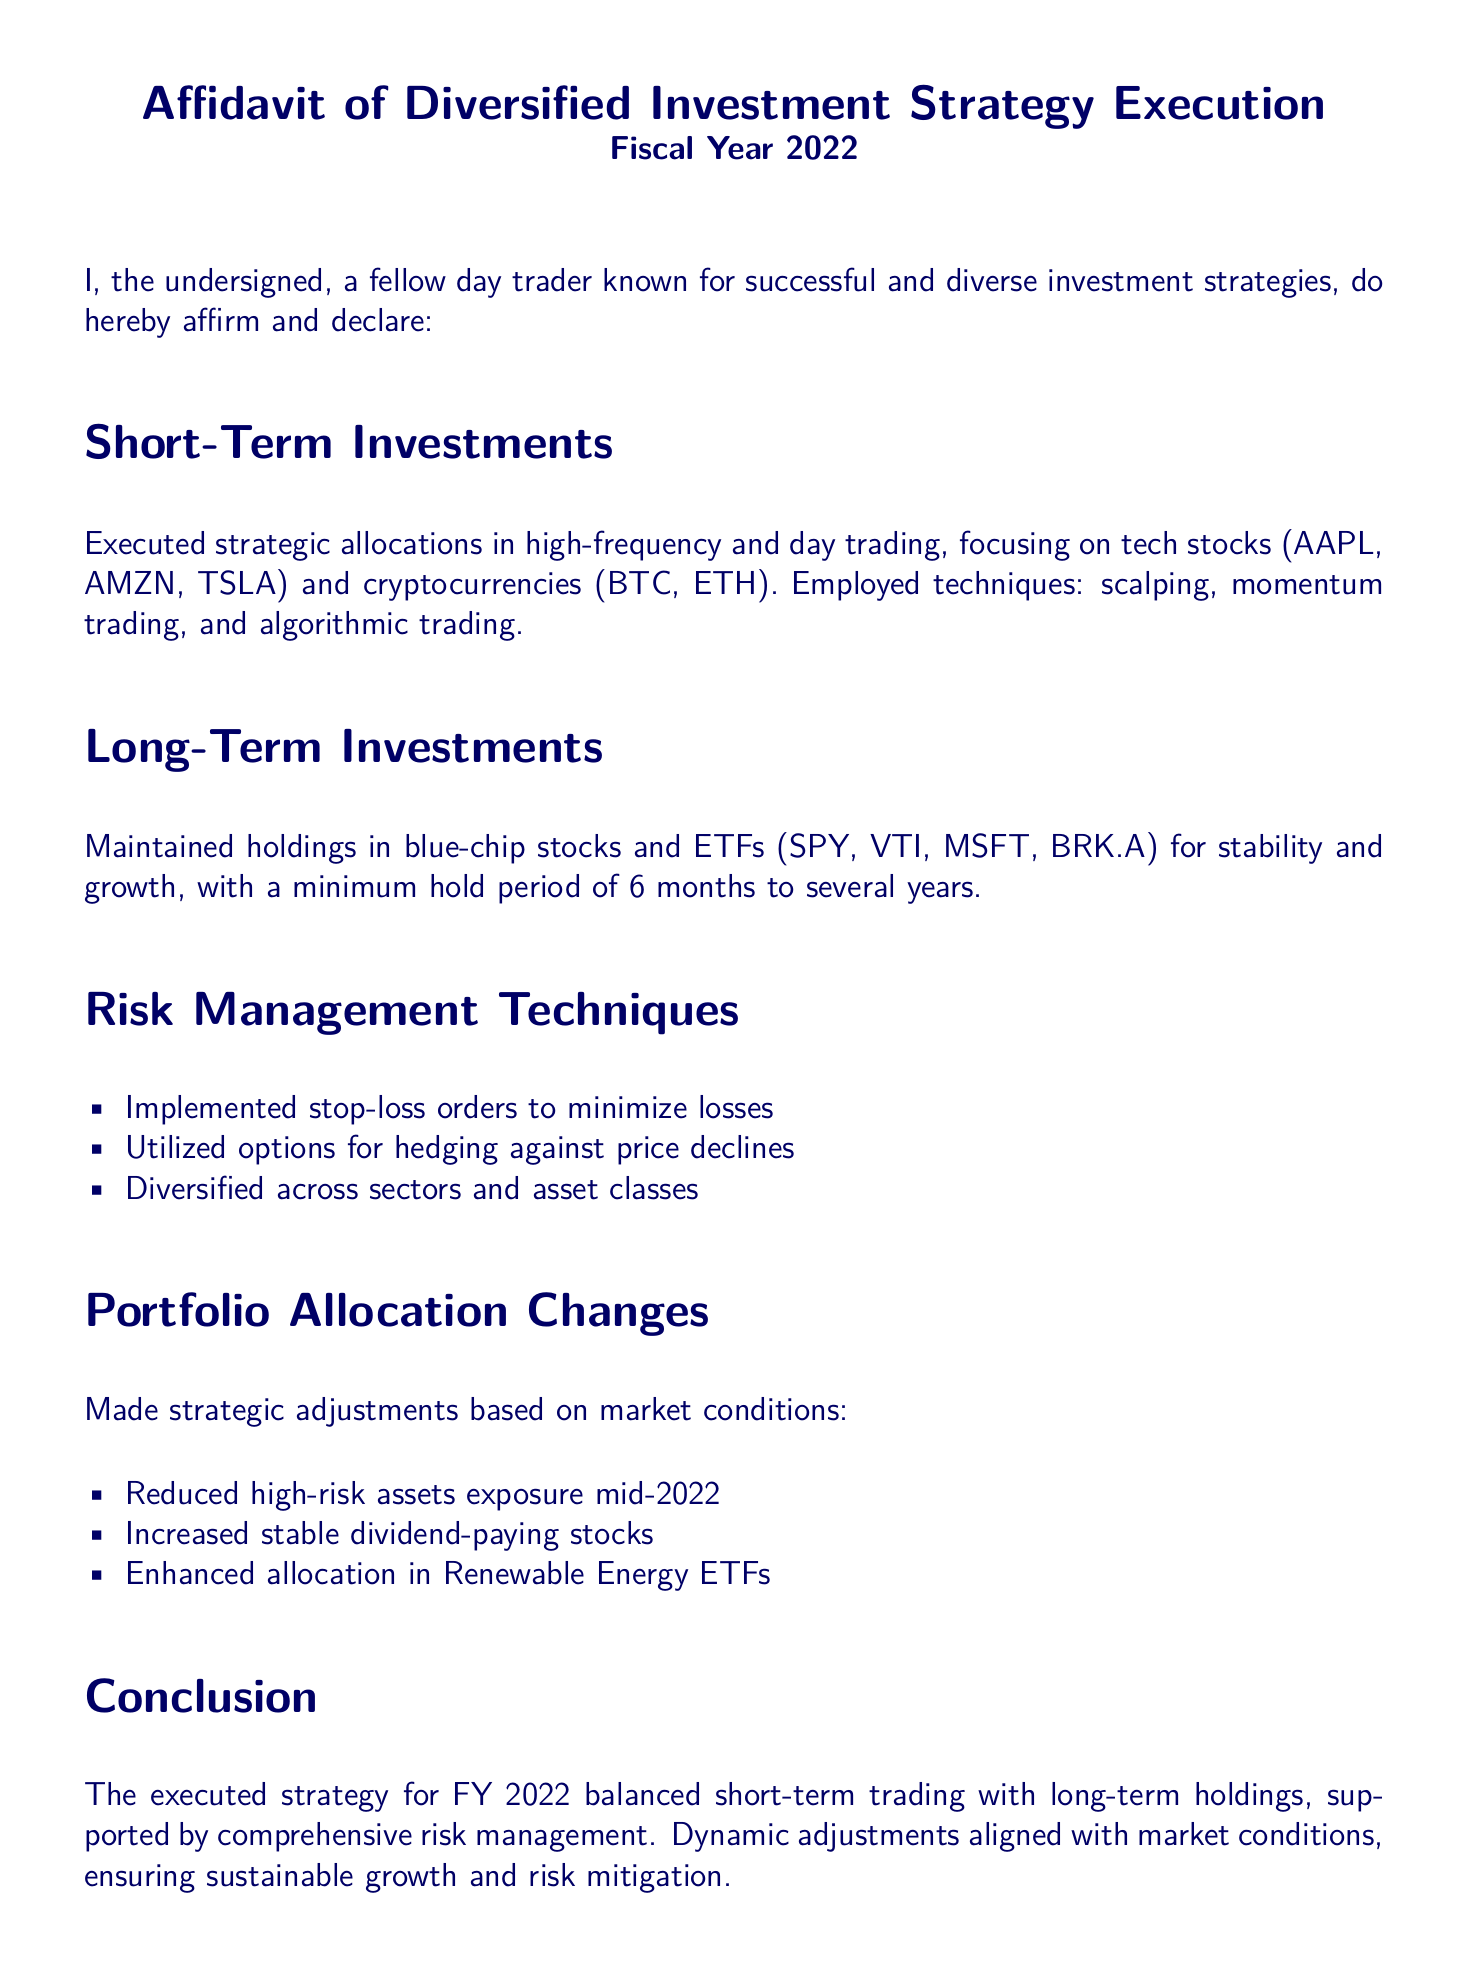What types of investments are included in short-term investments? The document mentions specific investments in tech stocks and cryptocurrencies under short-term investments.
Answer: tech stocks and cryptocurrencies What are the names of two cryptocurrencies mentioned? The affidavit lists specific cryptocurrencies focusing on short-term investments.
Answer: BTC, ETH How long is the minimum hold period for long-term investments? The document states a minimum hold period related to long-term investments.
Answer: 6 months What risk management technique involves minimizing losses? The affidavit details specific risk management techniques used during investment execution.
Answer: stop-loss orders What type of stocks was increased in the portfolio allocation changes? The document specifies the types of assets targeted for increase in response to market conditions.
Answer: stable dividend-paying stocks What was the allocation change made mid-2022? The affidavit lists a specific action taken regarding high-risk assets as part of portfolio allocation changes.
Answer: Reduced high-risk assets exposure What investment sector received enhanced allocation? The document outlines a specific sector that was targeted for increased investment during the year.
Answer: Renewable Energy ETFs What kind of trading techniques were employed in short-term investments? The affidavit identifies specific trading methods used within short-term investments.
Answer: scalping, momentum trading, and algorithmic trading Who is the undersigned of this affidavit? The document introduces the person affirming the statements made in the affidavit.
Answer: a fellow day trader 